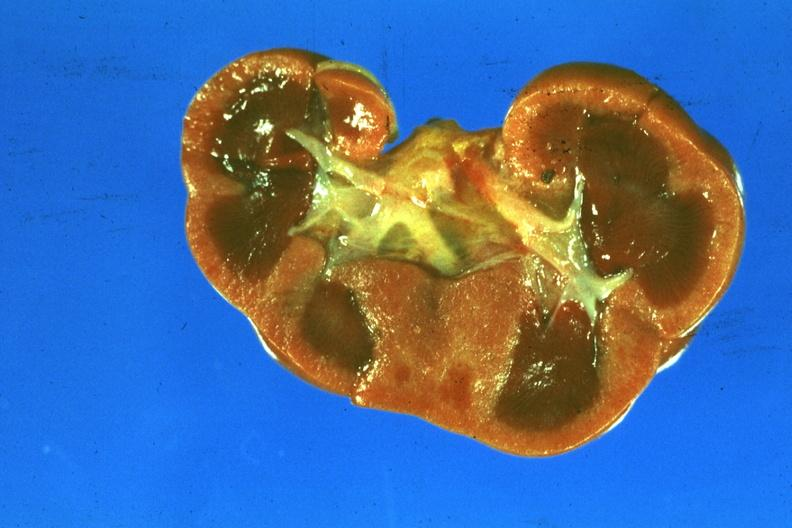s ischemia newborn present?
Answer the question using a single word or phrase. Yes 